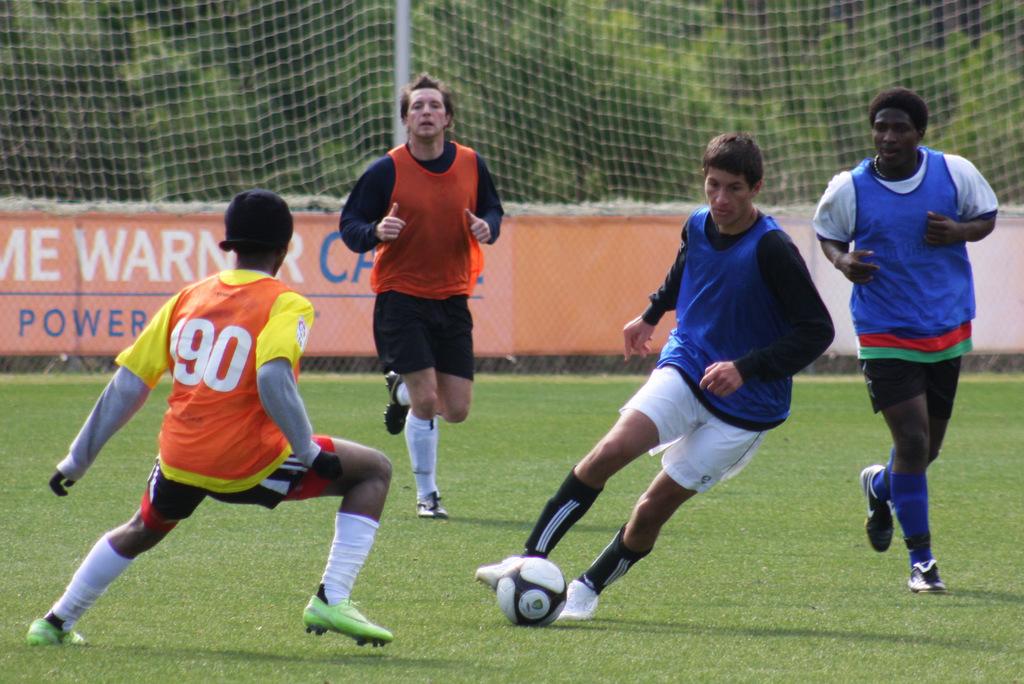What is the jersey number of the player in orange?
Your answer should be compact. 90. What number is the player in the yellow shirt?
Offer a terse response. 90. 